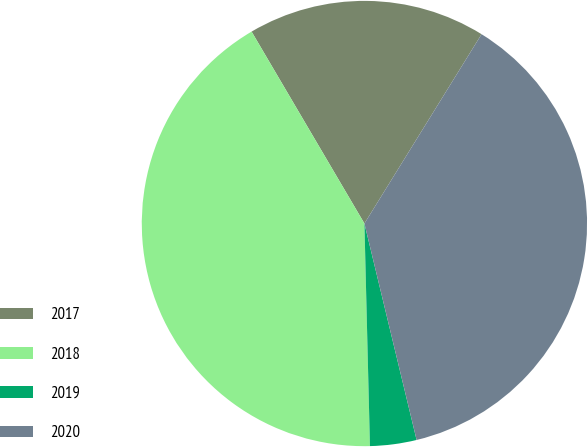Convert chart to OTSL. <chart><loc_0><loc_0><loc_500><loc_500><pie_chart><fcel>2017<fcel>2018<fcel>2019<fcel>2020<nl><fcel>17.28%<fcel>41.94%<fcel>3.37%<fcel>37.42%<nl></chart> 